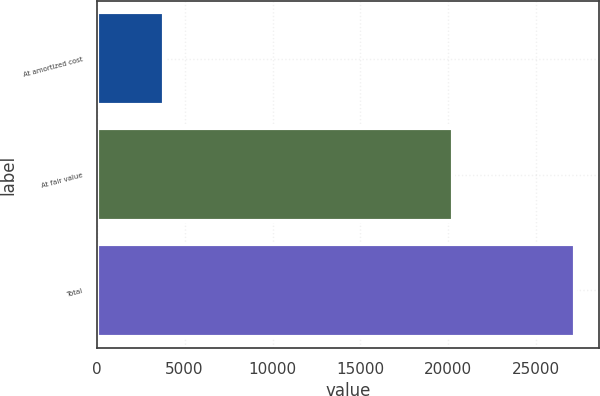Convert chart. <chart><loc_0><loc_0><loc_500><loc_500><bar_chart><fcel>At amortized cost<fcel>At fair value<fcel>Total<nl><fcel>3852<fcel>20284<fcel>27205<nl></chart> 